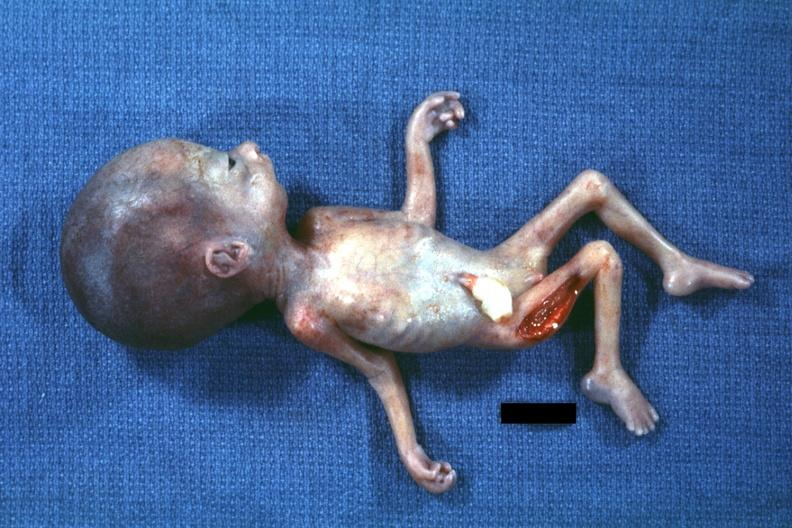s edema present?
Answer the question using a single word or phrase. No 